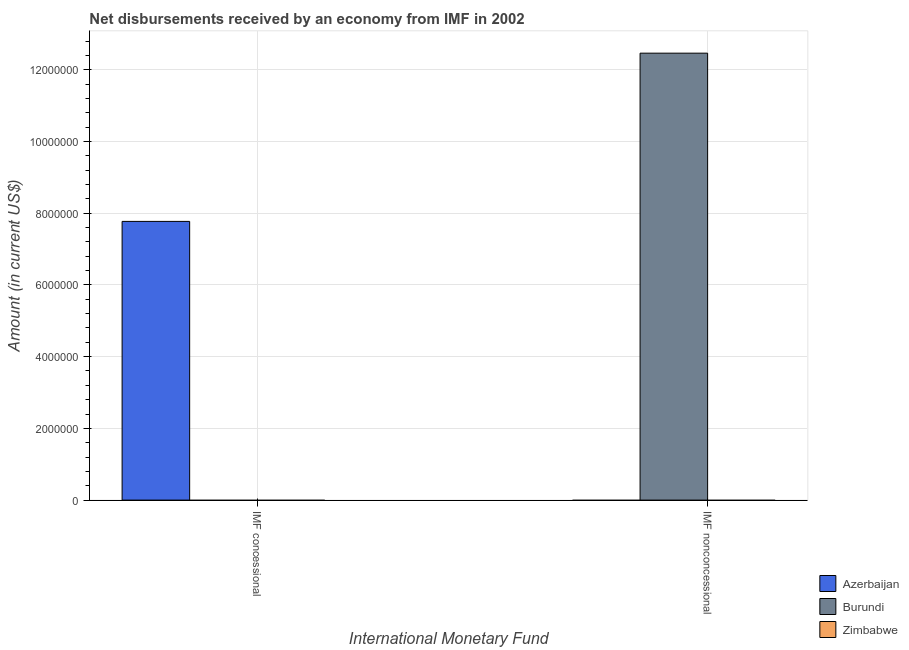How many different coloured bars are there?
Make the answer very short. 2. Are the number of bars on each tick of the X-axis equal?
Provide a short and direct response. Yes. How many bars are there on the 2nd tick from the left?
Give a very brief answer. 1. How many bars are there on the 1st tick from the right?
Your answer should be compact. 1. What is the label of the 1st group of bars from the left?
Offer a terse response. IMF concessional. What is the net concessional disbursements from imf in Azerbaijan?
Ensure brevity in your answer.  7.77e+06. Across all countries, what is the maximum net concessional disbursements from imf?
Offer a terse response. 7.77e+06. In which country was the net non concessional disbursements from imf maximum?
Your answer should be compact. Burundi. What is the total net non concessional disbursements from imf in the graph?
Provide a succinct answer. 1.25e+07. What is the difference between the net non concessional disbursements from imf in Zimbabwe and the net concessional disbursements from imf in Azerbaijan?
Ensure brevity in your answer.  -7.77e+06. What is the average net non concessional disbursements from imf per country?
Provide a succinct answer. 4.15e+06. In how many countries, is the net non concessional disbursements from imf greater than the average net non concessional disbursements from imf taken over all countries?
Make the answer very short. 1. Are all the bars in the graph horizontal?
Your response must be concise. No. How many countries are there in the graph?
Your answer should be compact. 3. What is the difference between two consecutive major ticks on the Y-axis?
Give a very brief answer. 2.00e+06. Where does the legend appear in the graph?
Provide a succinct answer. Bottom right. How are the legend labels stacked?
Give a very brief answer. Vertical. What is the title of the graph?
Ensure brevity in your answer.  Net disbursements received by an economy from IMF in 2002. What is the label or title of the X-axis?
Keep it short and to the point. International Monetary Fund. What is the label or title of the Y-axis?
Your answer should be very brief. Amount (in current US$). What is the Amount (in current US$) of Azerbaijan in IMF concessional?
Keep it short and to the point. 7.77e+06. What is the Amount (in current US$) in Burundi in IMF nonconcessional?
Make the answer very short. 1.25e+07. Across all International Monetary Fund, what is the maximum Amount (in current US$) of Azerbaijan?
Keep it short and to the point. 7.77e+06. Across all International Monetary Fund, what is the maximum Amount (in current US$) of Burundi?
Give a very brief answer. 1.25e+07. Across all International Monetary Fund, what is the minimum Amount (in current US$) in Azerbaijan?
Make the answer very short. 0. Across all International Monetary Fund, what is the minimum Amount (in current US$) of Burundi?
Provide a succinct answer. 0. What is the total Amount (in current US$) of Azerbaijan in the graph?
Your answer should be compact. 7.77e+06. What is the total Amount (in current US$) of Burundi in the graph?
Your response must be concise. 1.25e+07. What is the difference between the Amount (in current US$) in Azerbaijan in IMF concessional and the Amount (in current US$) in Burundi in IMF nonconcessional?
Keep it short and to the point. -4.69e+06. What is the average Amount (in current US$) of Azerbaijan per International Monetary Fund?
Your response must be concise. 3.89e+06. What is the average Amount (in current US$) of Burundi per International Monetary Fund?
Offer a very short reply. 6.23e+06. What is the average Amount (in current US$) of Zimbabwe per International Monetary Fund?
Provide a succinct answer. 0. What is the difference between the highest and the lowest Amount (in current US$) in Azerbaijan?
Give a very brief answer. 7.77e+06. What is the difference between the highest and the lowest Amount (in current US$) in Burundi?
Provide a short and direct response. 1.25e+07. 